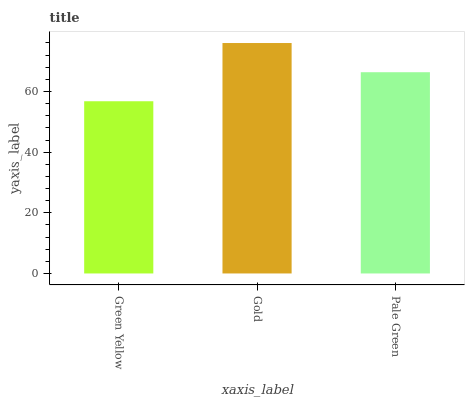Is Green Yellow the minimum?
Answer yes or no. Yes. Is Gold the maximum?
Answer yes or no. Yes. Is Pale Green the minimum?
Answer yes or no. No. Is Pale Green the maximum?
Answer yes or no. No. Is Gold greater than Pale Green?
Answer yes or no. Yes. Is Pale Green less than Gold?
Answer yes or no. Yes. Is Pale Green greater than Gold?
Answer yes or no. No. Is Gold less than Pale Green?
Answer yes or no. No. Is Pale Green the high median?
Answer yes or no. Yes. Is Pale Green the low median?
Answer yes or no. Yes. Is Green Yellow the high median?
Answer yes or no. No. Is Green Yellow the low median?
Answer yes or no. No. 